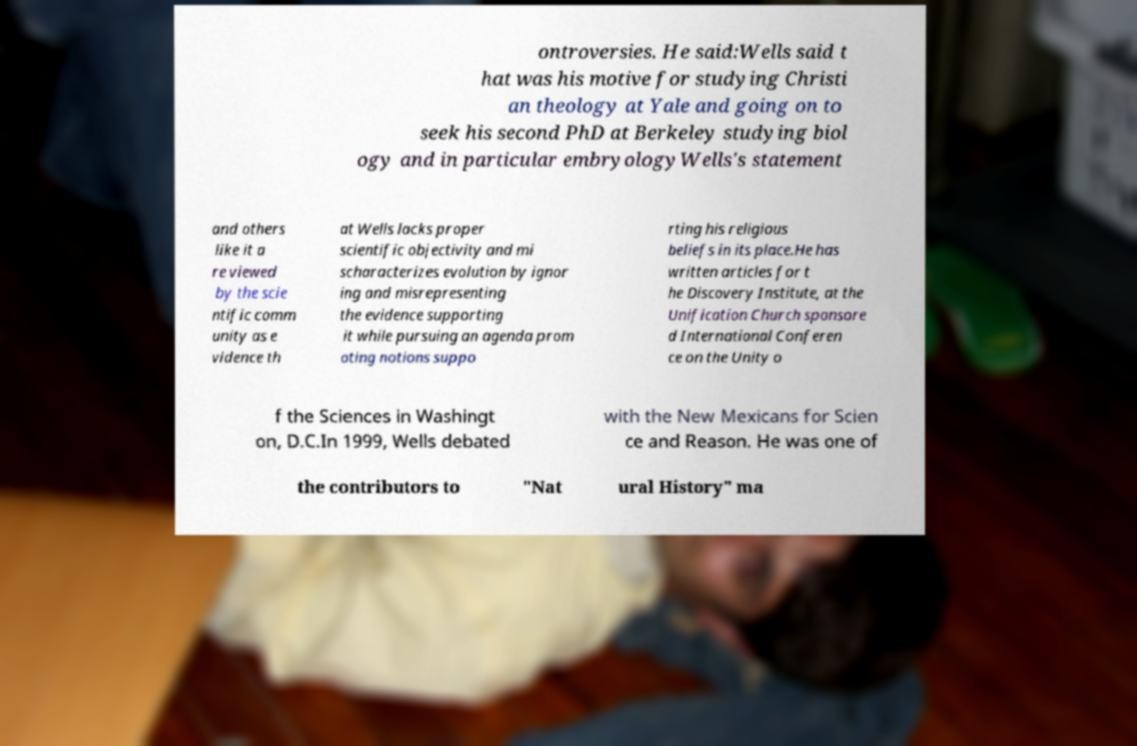Please identify and transcribe the text found in this image. ontroversies. He said:Wells said t hat was his motive for studying Christi an theology at Yale and going on to seek his second PhD at Berkeley studying biol ogy and in particular embryologyWells's statement and others like it a re viewed by the scie ntific comm unity as e vidence th at Wells lacks proper scientific objectivity and mi scharacterizes evolution by ignor ing and misrepresenting the evidence supporting it while pursuing an agenda prom oting notions suppo rting his religious beliefs in its place.He has written articles for t he Discovery Institute, at the Unification Church sponsore d International Conferen ce on the Unity o f the Sciences in Washingt on, D.C.In 1999, Wells debated with the New Mexicans for Scien ce and Reason. He was one of the contributors to "Nat ural History" ma 